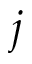<formula> <loc_0><loc_0><loc_500><loc_500>j</formula> 